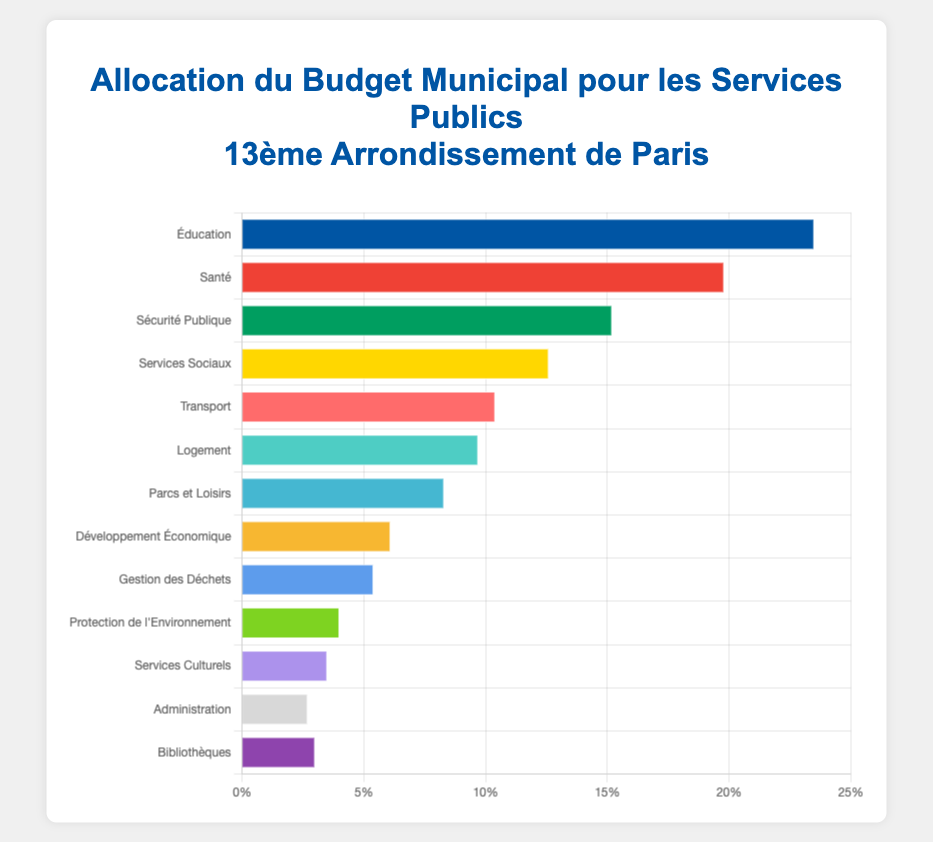How much more budget is allocated to Education than to Healthcare? The budget for Education is 23.5% and for Healthcare, it's 19.8%. Subtract the Healthcare budget from the Education budget: 23.5% - 19.8% = 3.7%.
Answer: 3.7% Which public service receives the least budget allocation? By examining the horizontal bar chart, we see that "Administration" has the shortest bar, indicating it receives the smallest portion of the budget at 2.7%.
Answer: Administration How much is the combined budget for Social Services, Housing, and Parks and Recreation? The budgets are 12.6% for Social Services, 9.7% for Housing, and 8.3% for Parks and Recreation. Adding these gives 12.6% + 9.7% + 8.3% = 30.6%.
Answer: 30.6% Which services have a budget greater than 10%? The services with budgets greater than 10% are Education (23.5%), Healthcare (19.8%), Public Safety (15.2%), and Social Services (12.6%).
Answer: Education, Healthcare, Public Safety, Social Services Compare the budget allocation for Transportation and Environmental Protection. Which is higher and by how much? Transportation has a budget of 10.4%. Environmental Protection has 4%. Subtracting Environmental Protection from Transportation gives 10.4% - 4% = 6.4%.
Answer: Transportation by 6.4% What is the total percentage of the budget allocated to Education, Healthcare, and Public Safety? Adding the budgets for Education (23.5%), Healthcare (19.8%), and Public Safety (15.2%) gives 23.5% + 19.8% + 15.2% = 58.5%.
Answer: 58.5% Which service has the closest budget to Cultural Services, and what is the difference between their budgets? Cultural Services has a budget of 3.5%. Libraries have a budget of 3.0%. The difference is 3.5% - 3.0% = 0.5%.
Answer: Libraries, 0.5% If the total budget is 100 million euros, how much money is allocated to Parks and Recreation? Parks and Recreation gets 8.3% of the budget. To find the amount, multiply 100 million euros by 8.3%: (100 million * 8.3%) = 8.3 million euros.
Answer: 8.3 million euros 